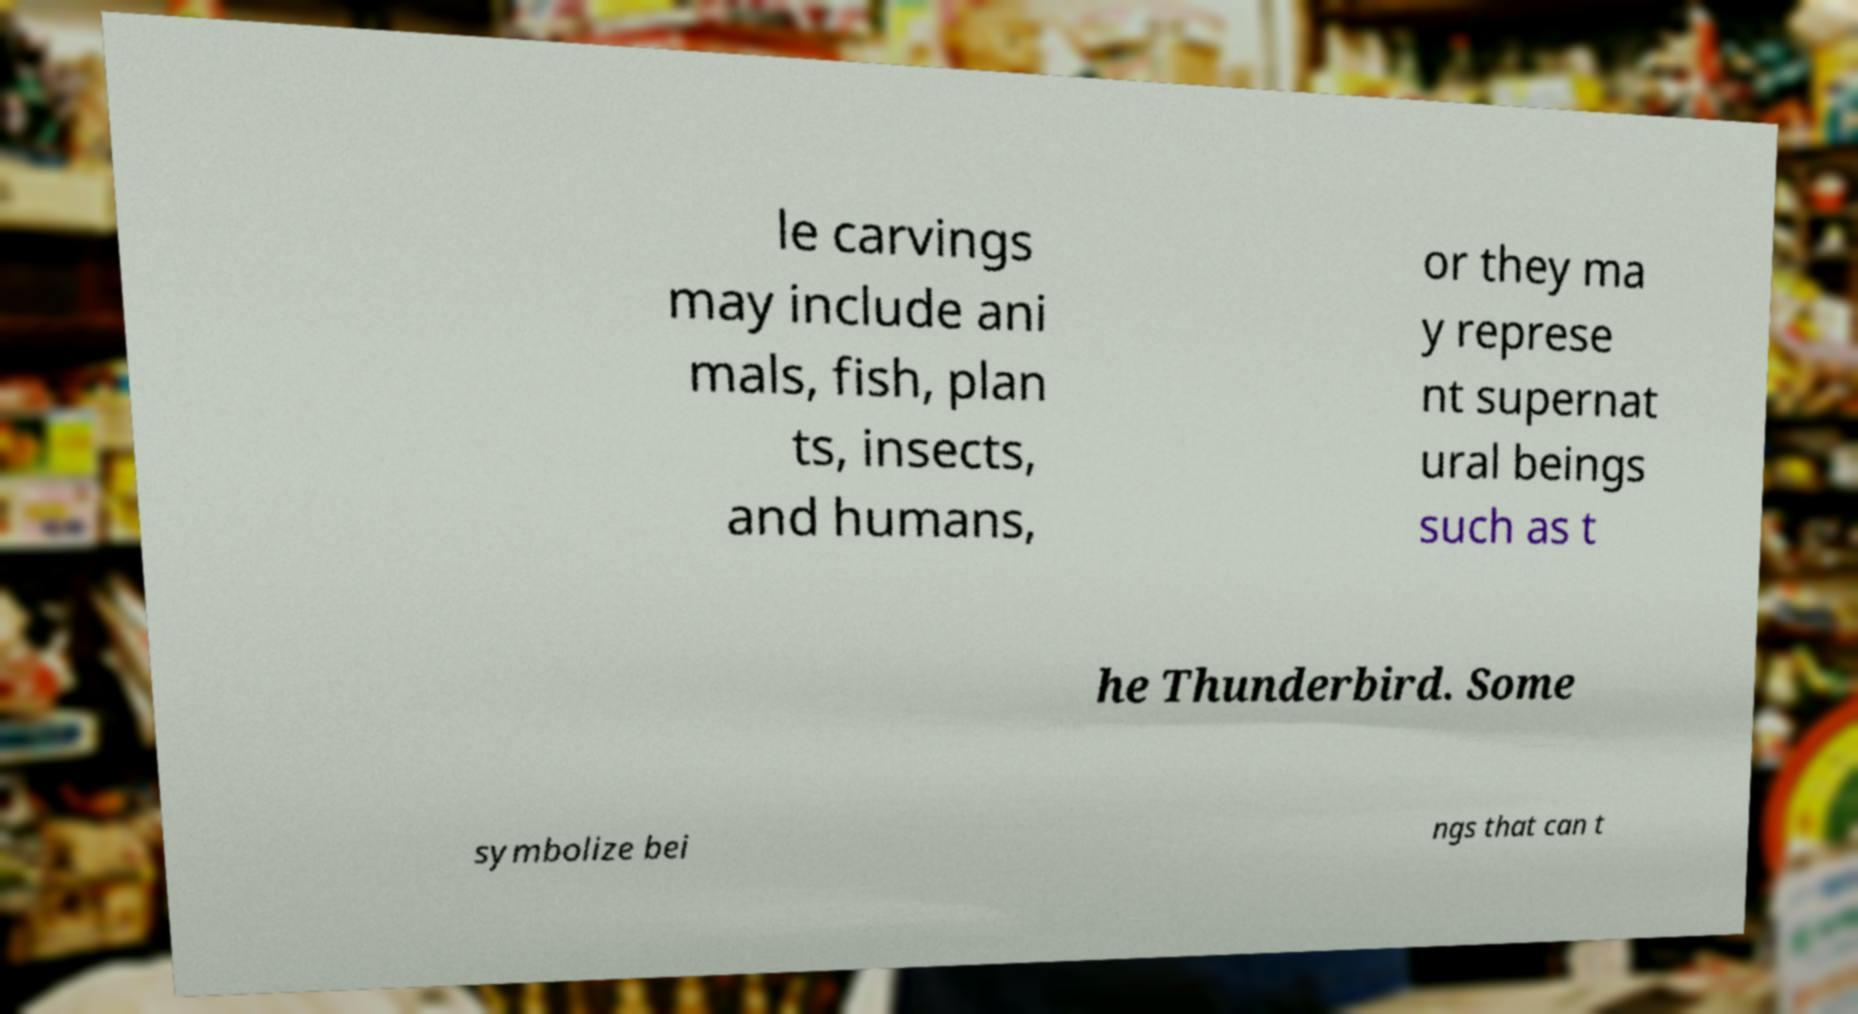What messages or text are displayed in this image? I need them in a readable, typed format. le carvings may include ani mals, fish, plan ts, insects, and humans, or they ma y represe nt supernat ural beings such as t he Thunderbird. Some symbolize bei ngs that can t 